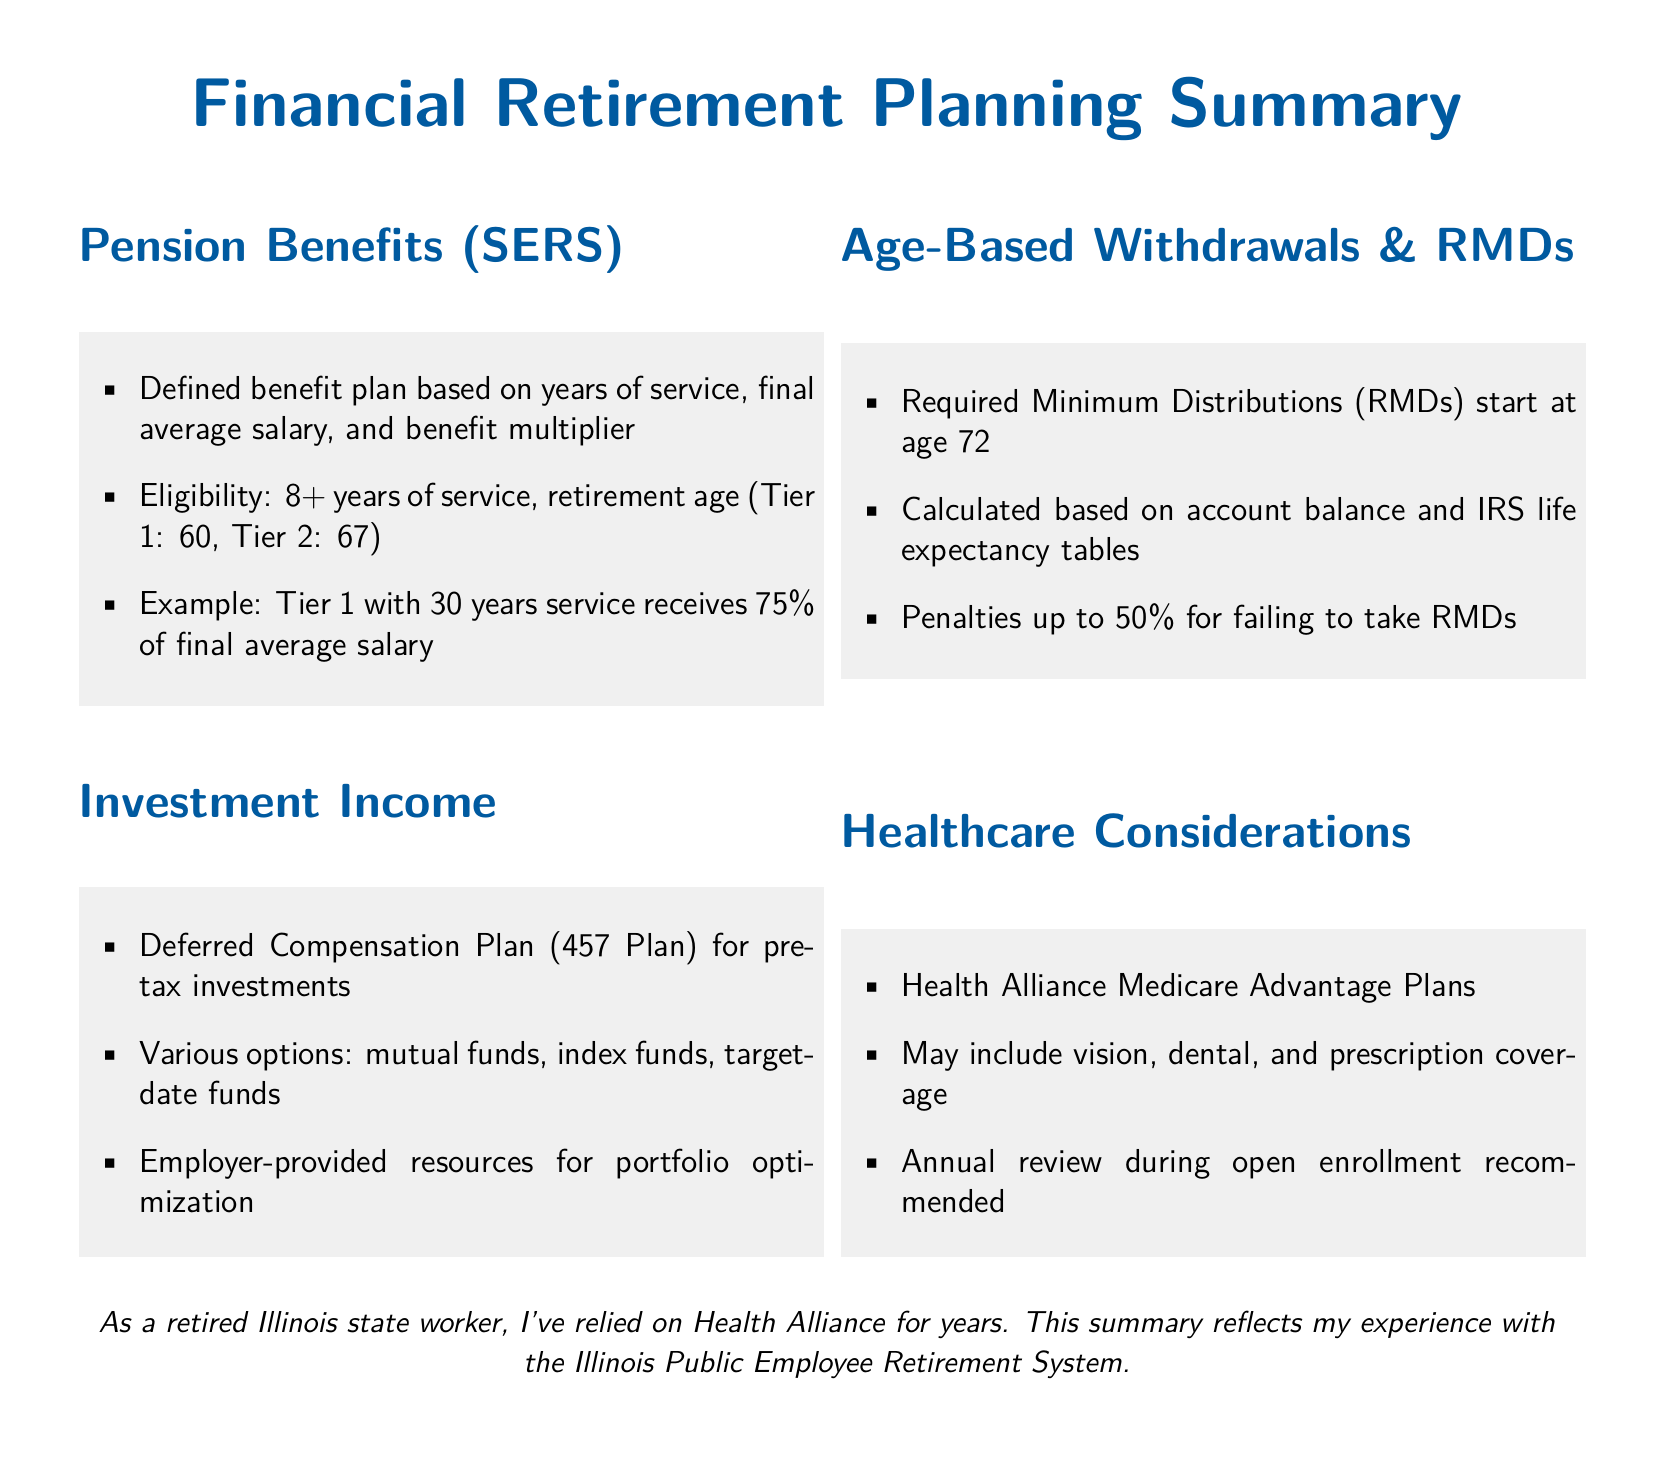what is the minimum years of service required for pension benefits? The document states that eligibility for pension benefits requires 8 or more years of service.
Answer: 8 years what percentage of final average salary does a Tier 1 employee with 30 years of service receive? According to the example provided, a Tier 1 employee with 30 years of service receives 75 percent of their final average salary.
Answer: 75% at what age do Required Minimum Distributions (RMDs) start? The document specifies that RMDs begin at age 72.
Answer: 72 what are the investment options mentioned in the Deferred Compensation Plan? The options outlined in the document include mutual funds, index funds, and target-date funds.
Answer: mutual funds, index funds, target-date funds what is the penalty percentage for failing to take RMDs? The document indicates that the penalty for not taking RMDs can be as high as 50 percent.
Answer: 50% what type of plans does Health Alliance provide for healthcare considerations? The text mentions Health Alliance Medicare Advantage Plans as part of healthcare considerations.
Answer: Medicare Advantage Plans what is recommended during open enrollment? The document advises conducting an annual review during open enrollment for healthcare options.
Answer: annual review 